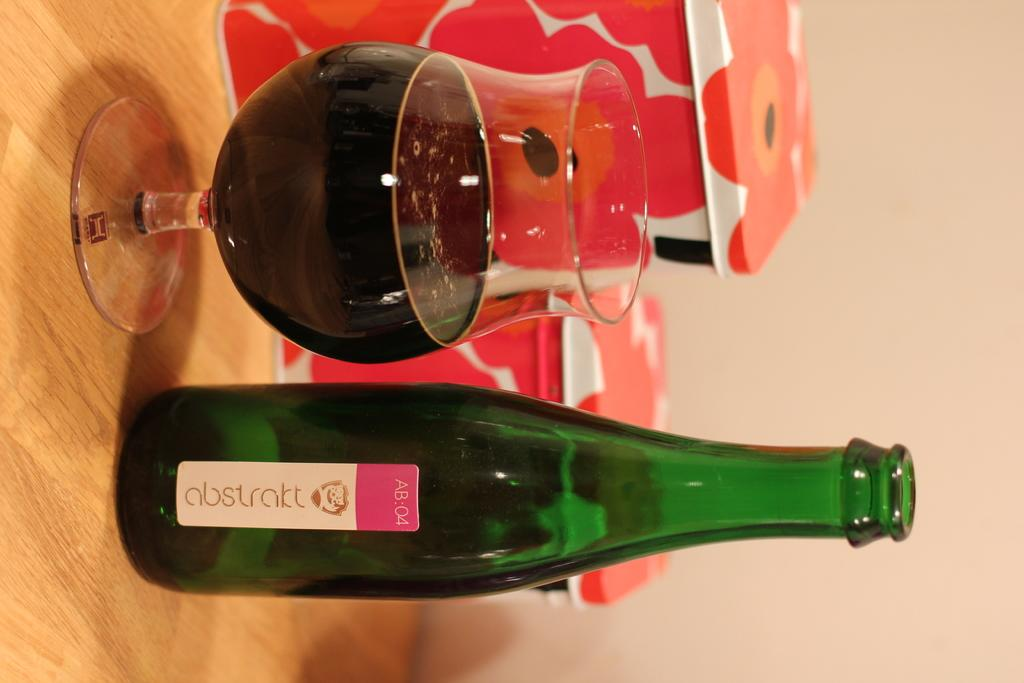Where is the image taken? The image is taken in a room. What furniture is present in the room? There is a table in the room. What items can be seen on the table? There is a glass, a bottle, and a box on the table. What is the background of the bottle? The background of the bottle is a wall. What type of food is being served on the cushion in the image? There is no cushion or food present in the image. 